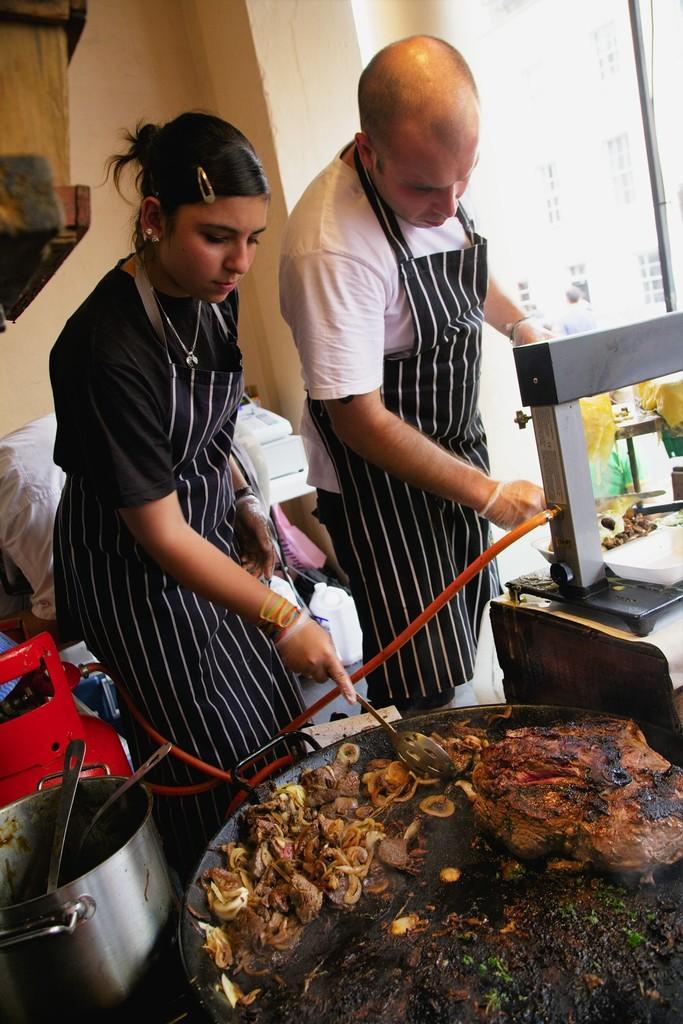Please provide a concise description of this image. The woman in black T-shirt is cooking food. Beside her, we see the man in white T- shirt is serving the food. Beside her, we see gas cylinder and a vessel. Behind them, we see a table on which white color things are placed. Behind that, we see a wall. On the right side, we see a building in white color. 